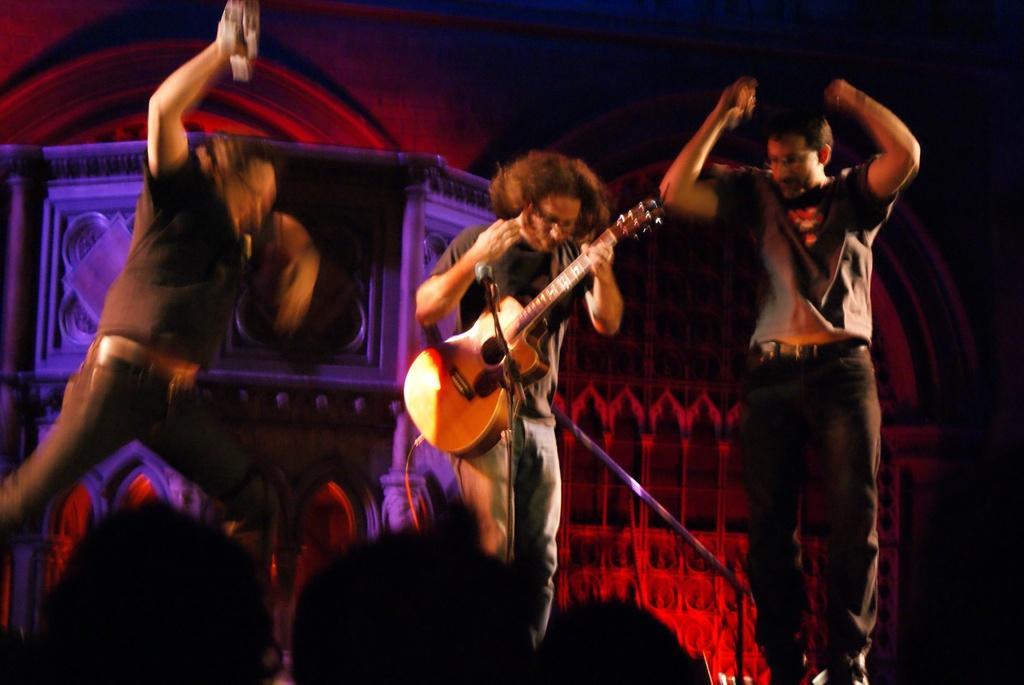Can you describe this image briefly? In this picture there is a man holding a guitar. There are two other men who are dancing. There is a mic. There are few other people. 